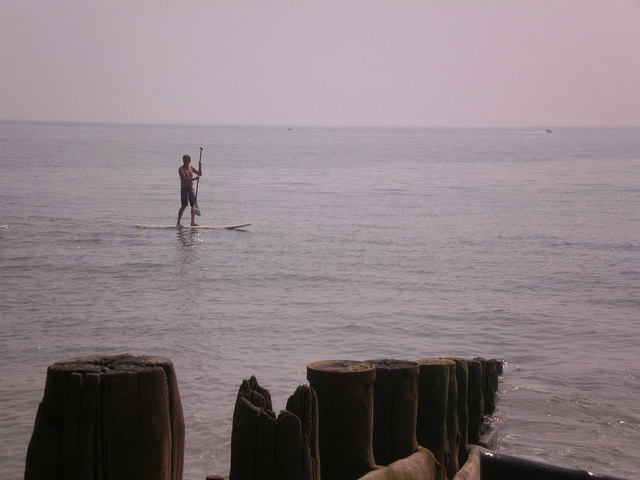Describe the objects in this image and their specific colors. I can see people in darkgray, black, and gray tones, surfboard in darkgray and gray tones, and boat in darkgray and gray tones in this image. 